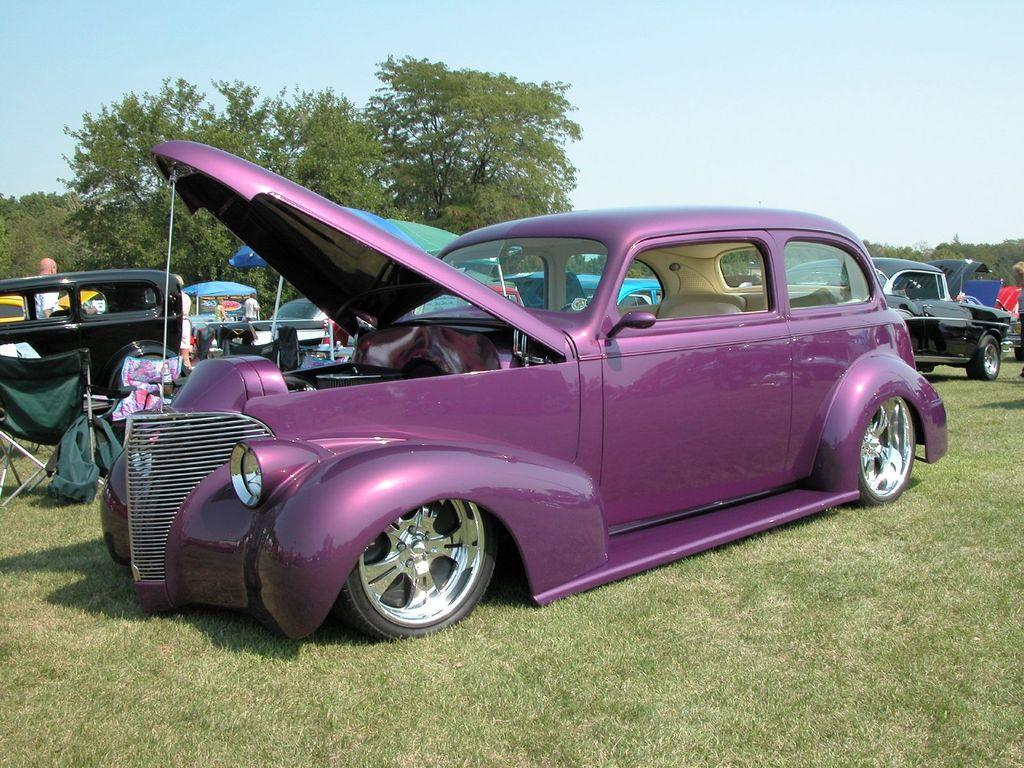What types of objects can be seen in the image? There are vehicles, umbrellas, people, grass, trees, and unspecified objects in the image. What is the natural environment like in the image? The natural environment includes grass and trees. What is visible in the background of the image? The sky is visible in the background of the image. How many birds are perched on the tent in the image? There is no tent or birds present in the image. What is the value of the unspecified objects in the image? The value of the unspecified objects cannot be determined from the image, as their nature and purpose are not clear. 